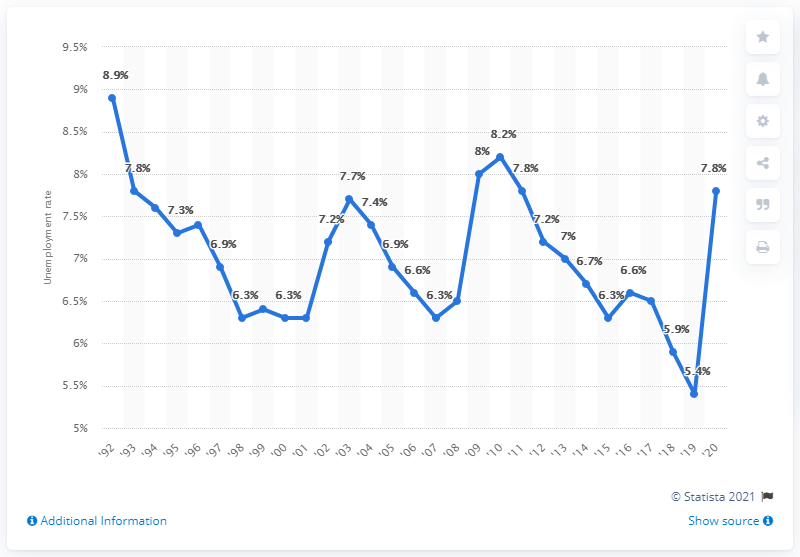What was Alaska's unemployment rate in 2020? According to the line graph displayed in the image, Alaska's unemployment rate in 2020 was approximately 5.4%, witnessing a sharp decline from the previous year. 